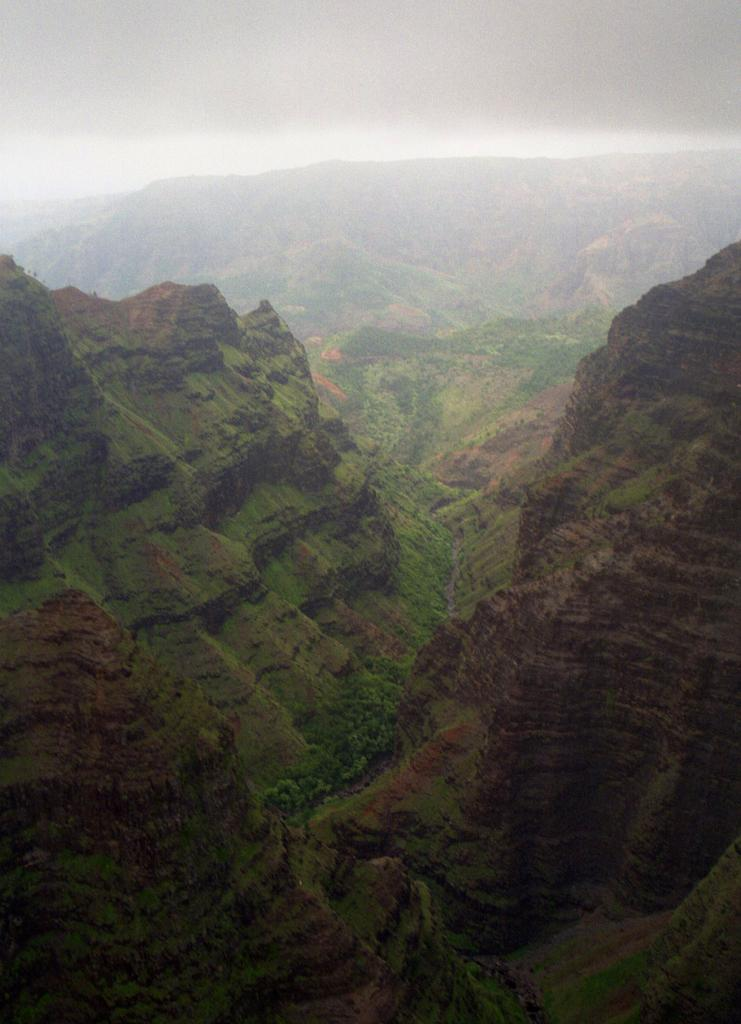What type of natural landform can be seen in the image? There are mountains in the image. What other natural elements are present in the image? There are trees in the image. What part of the sky is visible in the image? The sky is visible in the image. What can be observed in the sky? Clouds are present in the sky. Can you see the person's toe sticking out from under the tree in the image? There is no person or toe visible in the image; it only features mountains, trees, and the sky. 